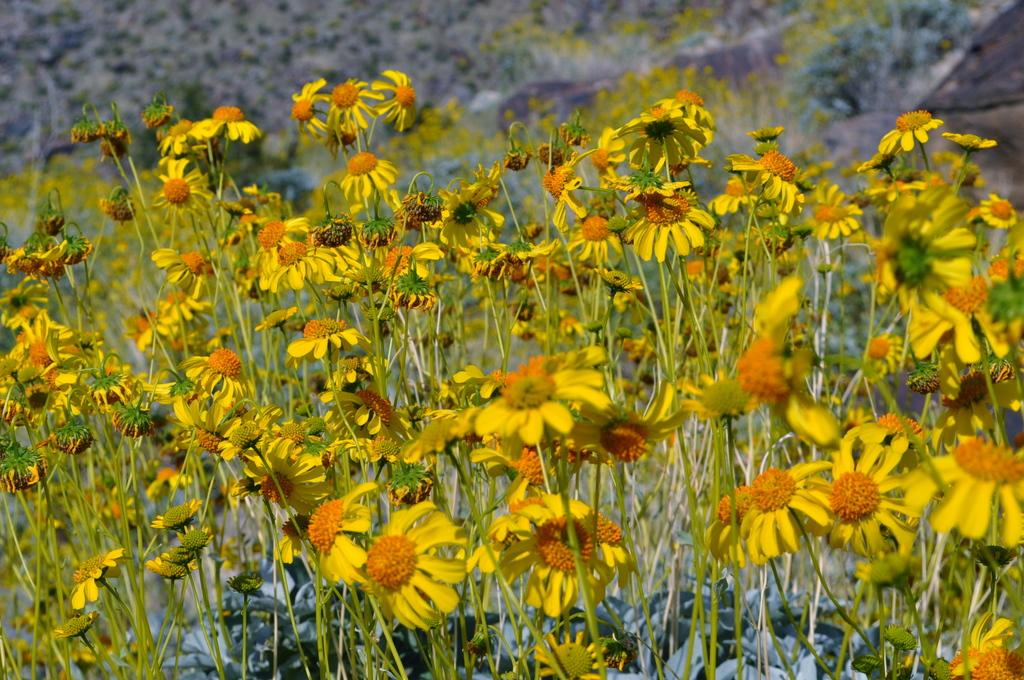What type of living organisms can be seen in the image? Plants can be seen in the image. What color are the flowers on the plants? The flowers on the plants are yellow. Can you describe the background of the image? The background of the image is blurred. What type of music is the band playing in the background of the image? There is no band present in the image, so it is not possible to determine what type of music they might be playing. 